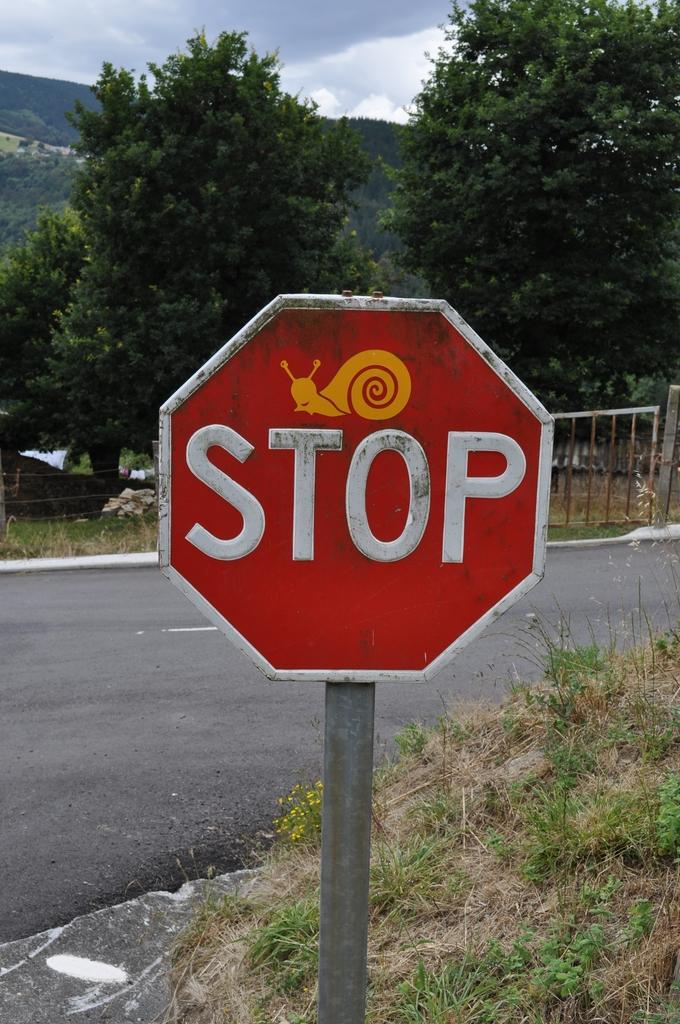What is the main object in the image? There is a sign board in the image. What is depicted on the sign board? The sign board has a snail image on it. What can be seen in the background of the image? The sky, mountains, and trees are visible in the image. What type of coal is being used to power the apparatus in the image? There is no coal or apparatus present in the image; it features a sign board with a snail image and a background with mountains, trees, and the sky. 